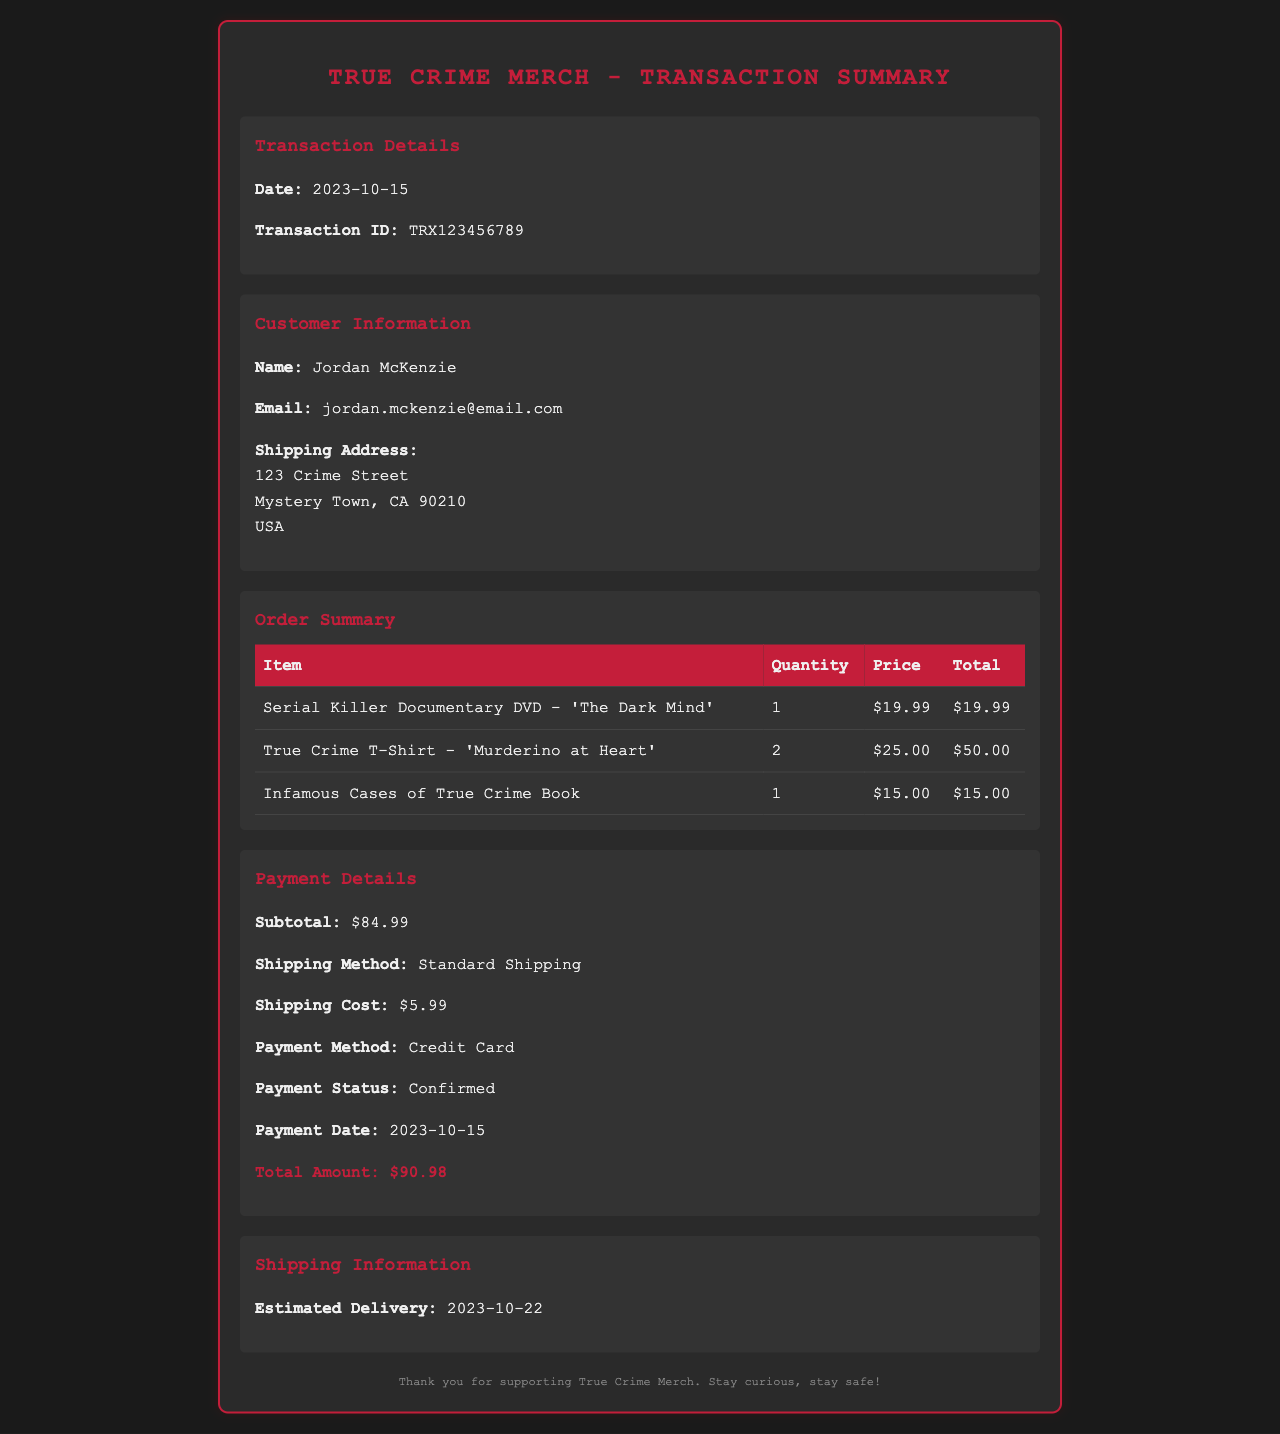What is the transaction date? The transaction date is mentioned in the document under Transaction Details.
Answer: 2023-10-15 Who is the customer? The customer's name is provided in the Customer Information section of the document.
Answer: Jordan McKenzie What items were purchased? The Order Summary section lists all items included in the transaction.
Answer: Serial Killer Documentary DVD - 'The Dark Mind', True Crime T-Shirt - 'Murderino at Heart', Infamous Cases of True Crime Book How many T-shirts were ordered? The Order Summary specifies the quantity for each item, particularly the T-shirts.
Answer: 2 What is the total amount charged? The total amount is calculated from the subtotal and shipping cost as displayed in Payment Details.
Answer: $90.98 What was the payment method used? The Payment Details section indicates the type of payment used for the transaction.
Answer: Credit Card What is the estimated delivery date? The estimated delivery date is provided in the Shipping Information section.
Answer: 2023-10-22 What was the shipping cost? The shipping cost is included in the Payment Details section of the document.
Answer: $5.99 What is the transaction ID? The transaction ID is mentioned in the transaction details of the document.
Answer: TRX123456789 